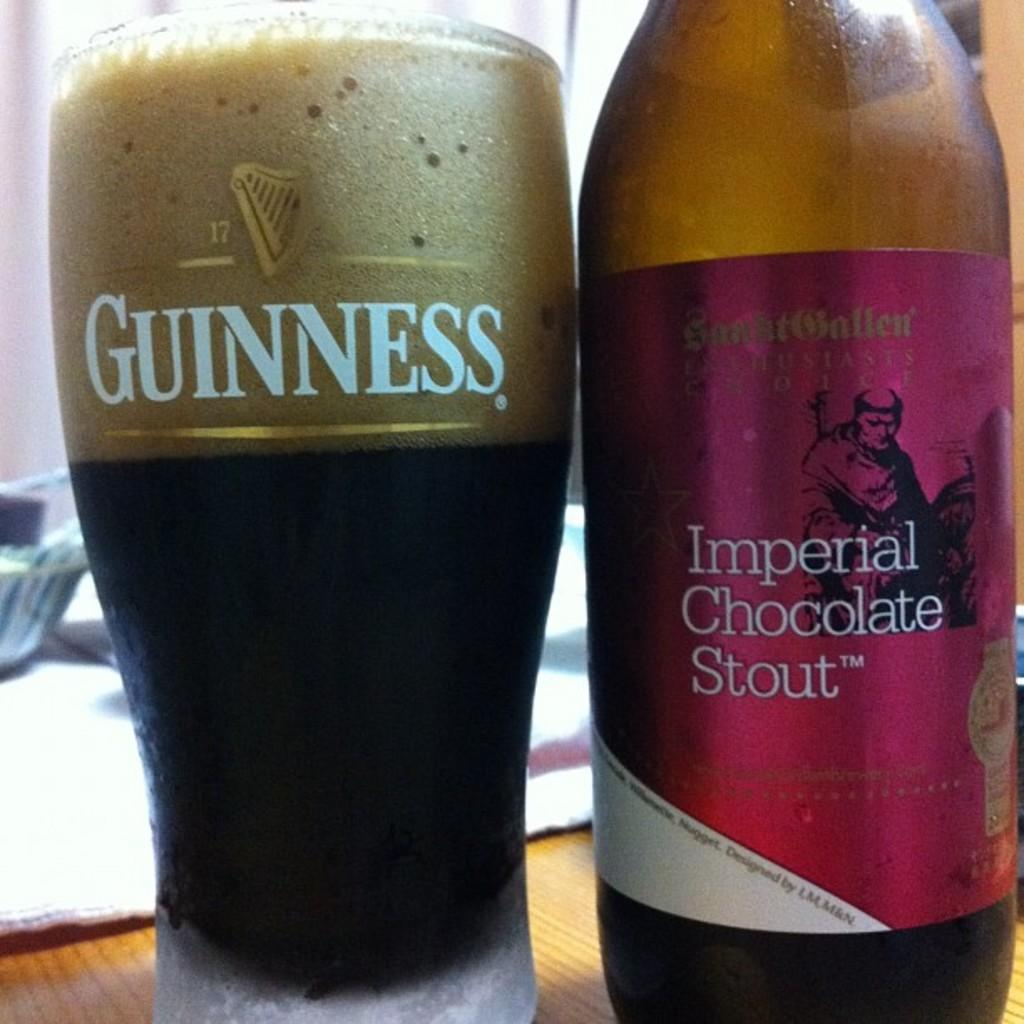<image>
Describe the image concisely. A Guiness glass and a bottle of Imperial Chocolate Stout beer. 